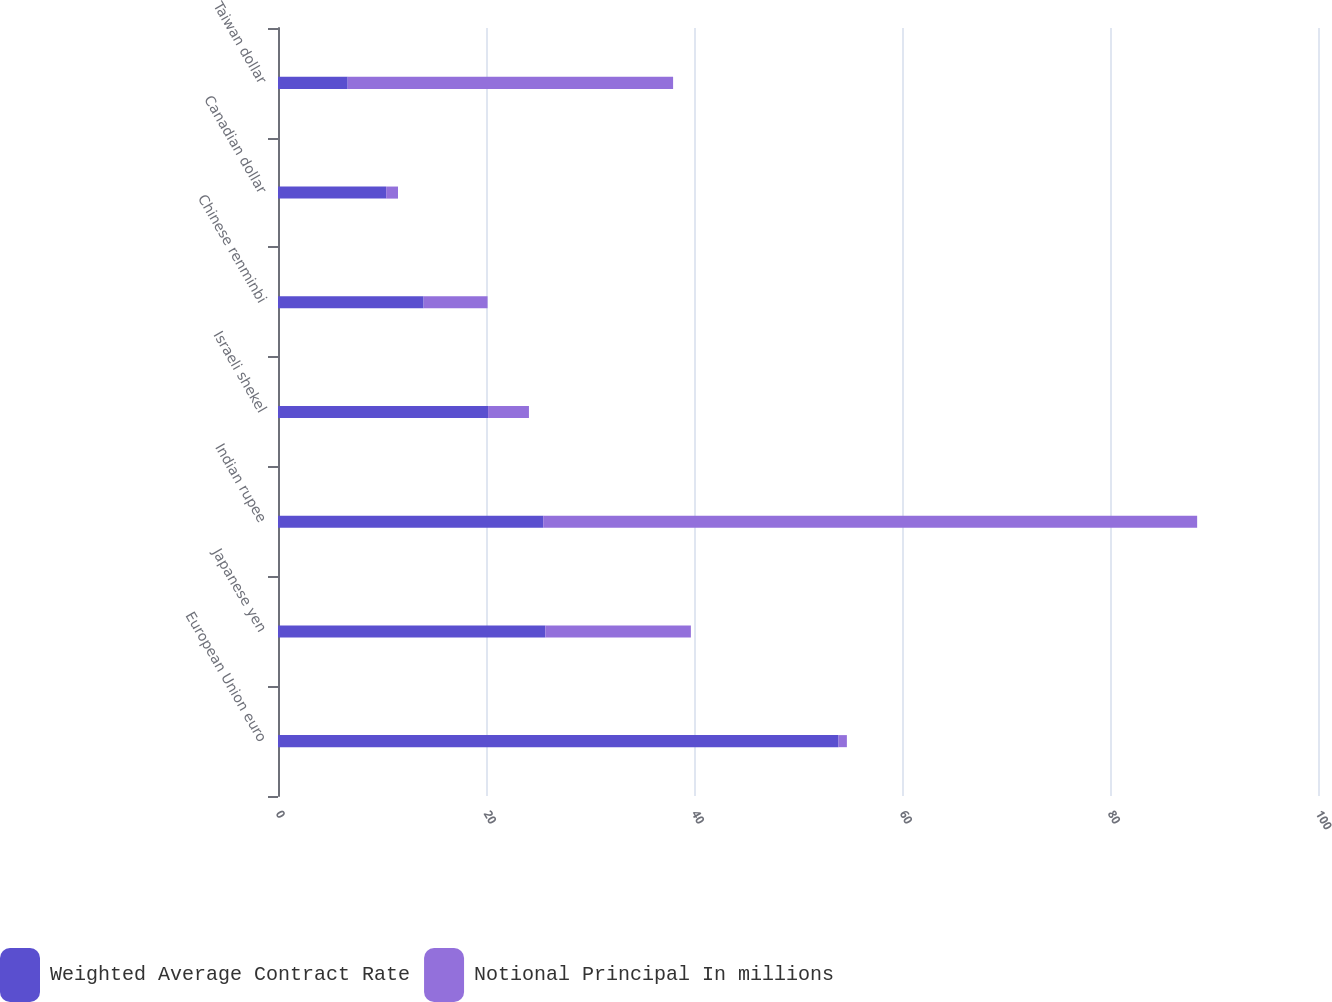Convert chart. <chart><loc_0><loc_0><loc_500><loc_500><stacked_bar_chart><ecel><fcel>European Union euro<fcel>Japanese yen<fcel>Indian rupee<fcel>Israeli shekel<fcel>Chinese renminbi<fcel>Canadian dollar<fcel>Taiwan dollar<nl><fcel>Weighted Average Contract Rate<fcel>53.9<fcel>25.7<fcel>25.5<fcel>20.2<fcel>14<fcel>10.4<fcel>6.7<nl><fcel>Notional Principal In millions<fcel>0.8<fcel>14<fcel>62.88<fcel>3.93<fcel>6.15<fcel>1.14<fcel>31.29<nl></chart> 